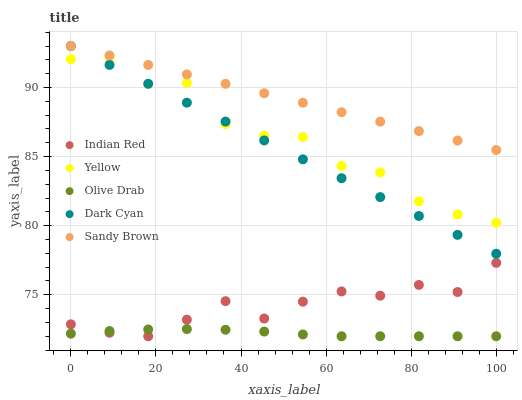Does Olive Drab have the minimum area under the curve?
Answer yes or no. Yes. Does Sandy Brown have the maximum area under the curve?
Answer yes or no. Yes. Does Sandy Brown have the minimum area under the curve?
Answer yes or no. No. Does Olive Drab have the maximum area under the curve?
Answer yes or no. No. Is Sandy Brown the smoothest?
Answer yes or no. Yes. Is Yellow the roughest?
Answer yes or no. Yes. Is Olive Drab the smoothest?
Answer yes or no. No. Is Olive Drab the roughest?
Answer yes or no. No. Does Olive Drab have the lowest value?
Answer yes or no. Yes. Does Sandy Brown have the lowest value?
Answer yes or no. No. Does Sandy Brown have the highest value?
Answer yes or no. Yes. Does Olive Drab have the highest value?
Answer yes or no. No. Is Olive Drab less than Dark Cyan?
Answer yes or no. Yes. Is Sandy Brown greater than Yellow?
Answer yes or no. Yes. Does Dark Cyan intersect Sandy Brown?
Answer yes or no. Yes. Is Dark Cyan less than Sandy Brown?
Answer yes or no. No. Is Dark Cyan greater than Sandy Brown?
Answer yes or no. No. Does Olive Drab intersect Dark Cyan?
Answer yes or no. No. 